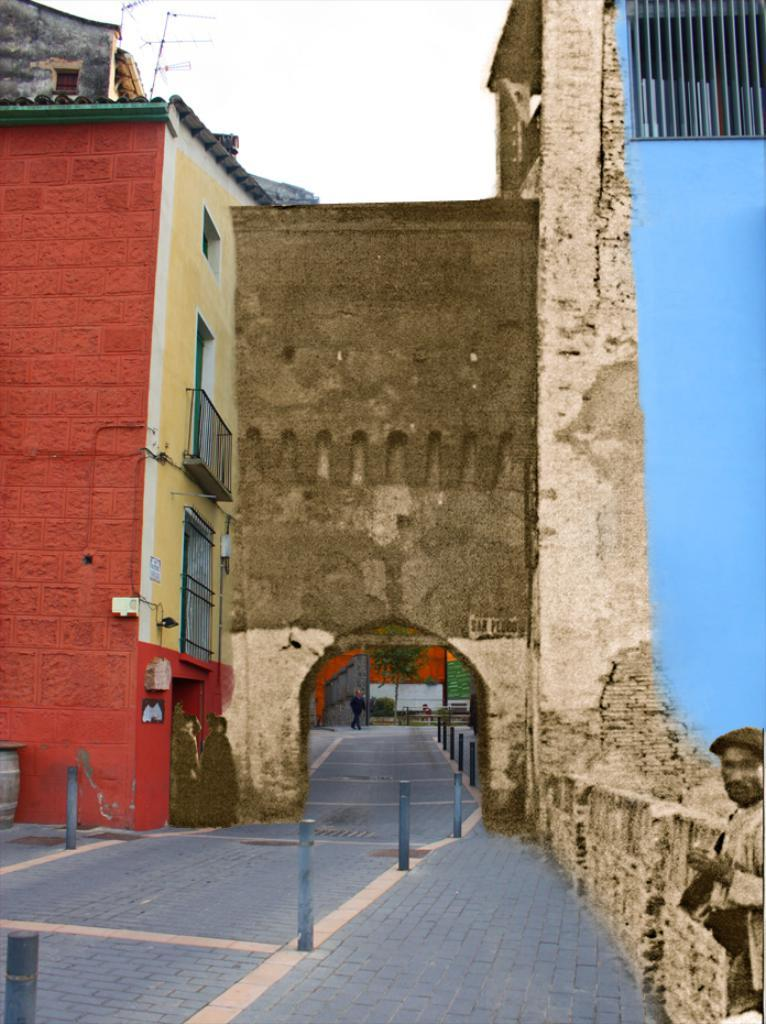What is the main action of the person in the image? The person is walking in the image. Where is the person walking? The person is walking on a path. What can be seen along the path? There are poles on the path. What is in front of the person? There are buildings in front of the person. What can be seen in the background of the image? The sky is visible behind the buildings. What type of hammer is the frog holding in the image? There is no frog or hammer present in the image. 